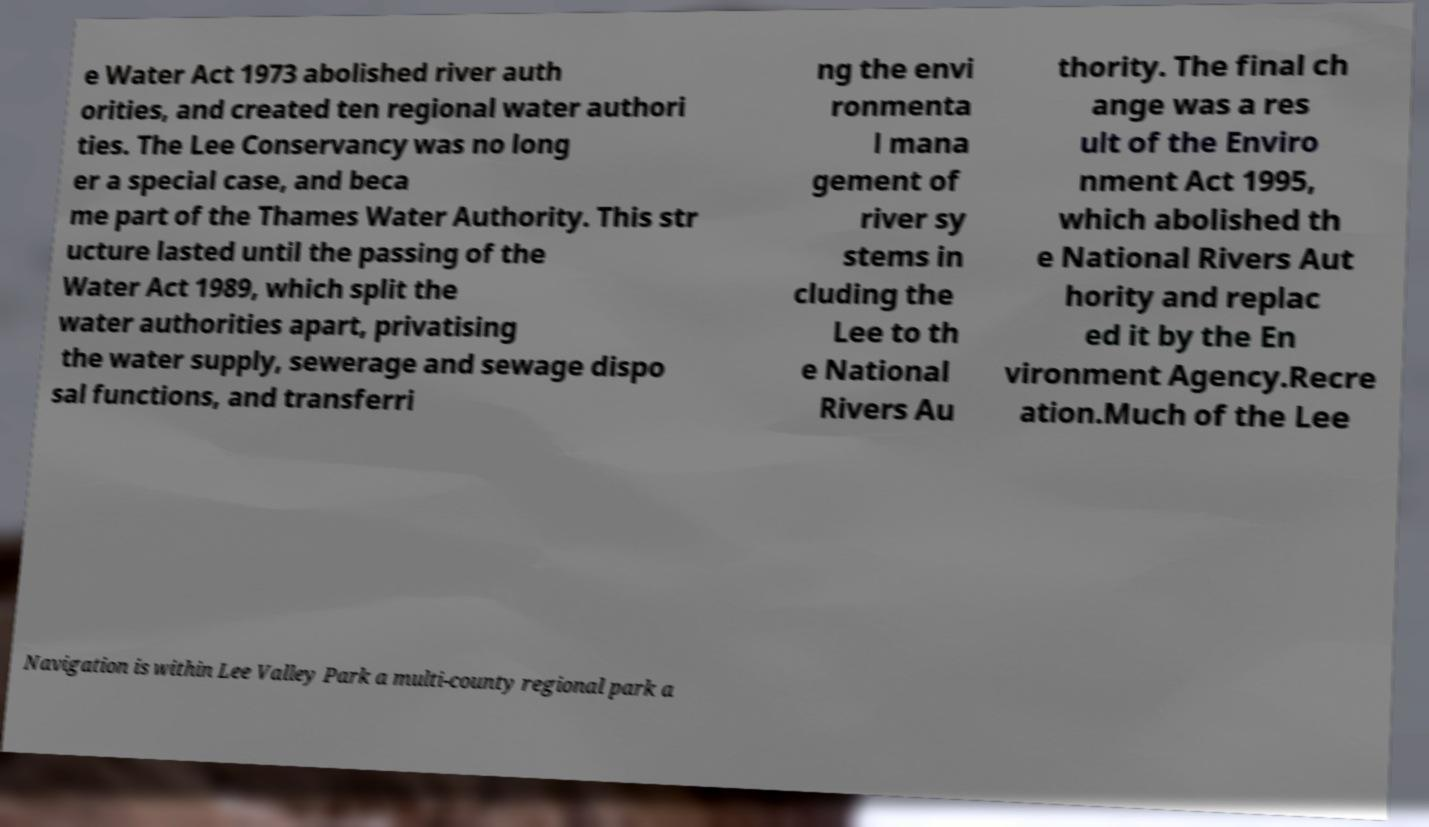Could you assist in decoding the text presented in this image and type it out clearly? e Water Act 1973 abolished river auth orities, and created ten regional water authori ties. The Lee Conservancy was no long er a special case, and beca me part of the Thames Water Authority. This str ucture lasted until the passing of the Water Act 1989, which split the water authorities apart, privatising the water supply, sewerage and sewage dispo sal functions, and transferri ng the envi ronmenta l mana gement of river sy stems in cluding the Lee to th e National Rivers Au thority. The final ch ange was a res ult of the Enviro nment Act 1995, which abolished th e National Rivers Aut hority and replac ed it by the En vironment Agency.Recre ation.Much of the Lee Navigation is within Lee Valley Park a multi-county regional park a 